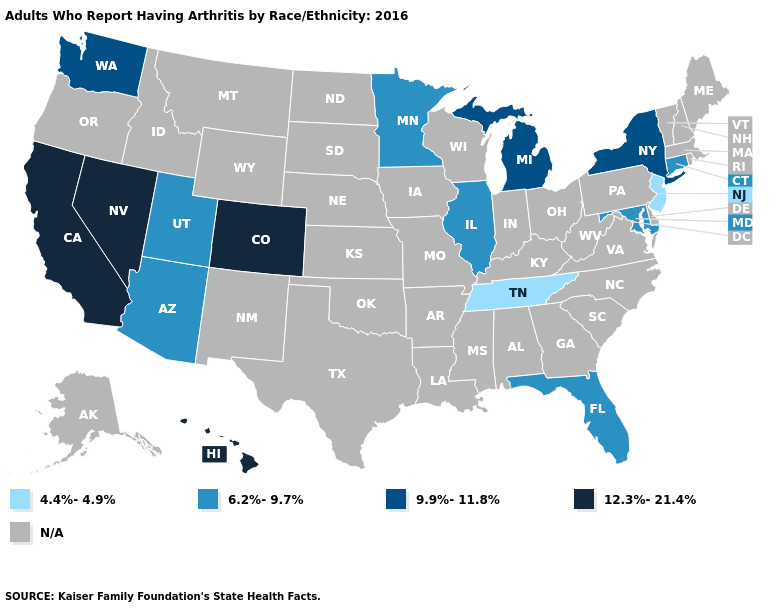How many symbols are there in the legend?
Be succinct. 5. What is the value of Minnesota?
Quick response, please. 6.2%-9.7%. What is the value of Indiana?
Keep it brief. N/A. Name the states that have a value in the range N/A?
Concise answer only. Alabama, Alaska, Arkansas, Delaware, Georgia, Idaho, Indiana, Iowa, Kansas, Kentucky, Louisiana, Maine, Massachusetts, Mississippi, Missouri, Montana, Nebraska, New Hampshire, New Mexico, North Carolina, North Dakota, Ohio, Oklahoma, Oregon, Pennsylvania, Rhode Island, South Carolina, South Dakota, Texas, Vermont, Virginia, West Virginia, Wisconsin, Wyoming. Which states have the highest value in the USA?
Keep it brief. California, Colorado, Hawaii, Nevada. Which states hav the highest value in the South?
Concise answer only. Florida, Maryland. Name the states that have a value in the range N/A?
Quick response, please. Alabama, Alaska, Arkansas, Delaware, Georgia, Idaho, Indiana, Iowa, Kansas, Kentucky, Louisiana, Maine, Massachusetts, Mississippi, Missouri, Montana, Nebraska, New Hampshire, New Mexico, North Carolina, North Dakota, Ohio, Oklahoma, Oregon, Pennsylvania, Rhode Island, South Carolina, South Dakota, Texas, Vermont, Virginia, West Virginia, Wisconsin, Wyoming. Name the states that have a value in the range 4.4%-4.9%?
Keep it brief. New Jersey, Tennessee. What is the value of Michigan?
Give a very brief answer. 9.9%-11.8%. Name the states that have a value in the range 12.3%-21.4%?
Answer briefly. California, Colorado, Hawaii, Nevada. Does the first symbol in the legend represent the smallest category?
Be succinct. Yes. What is the highest value in the MidWest ?
Short answer required. 9.9%-11.8%. 